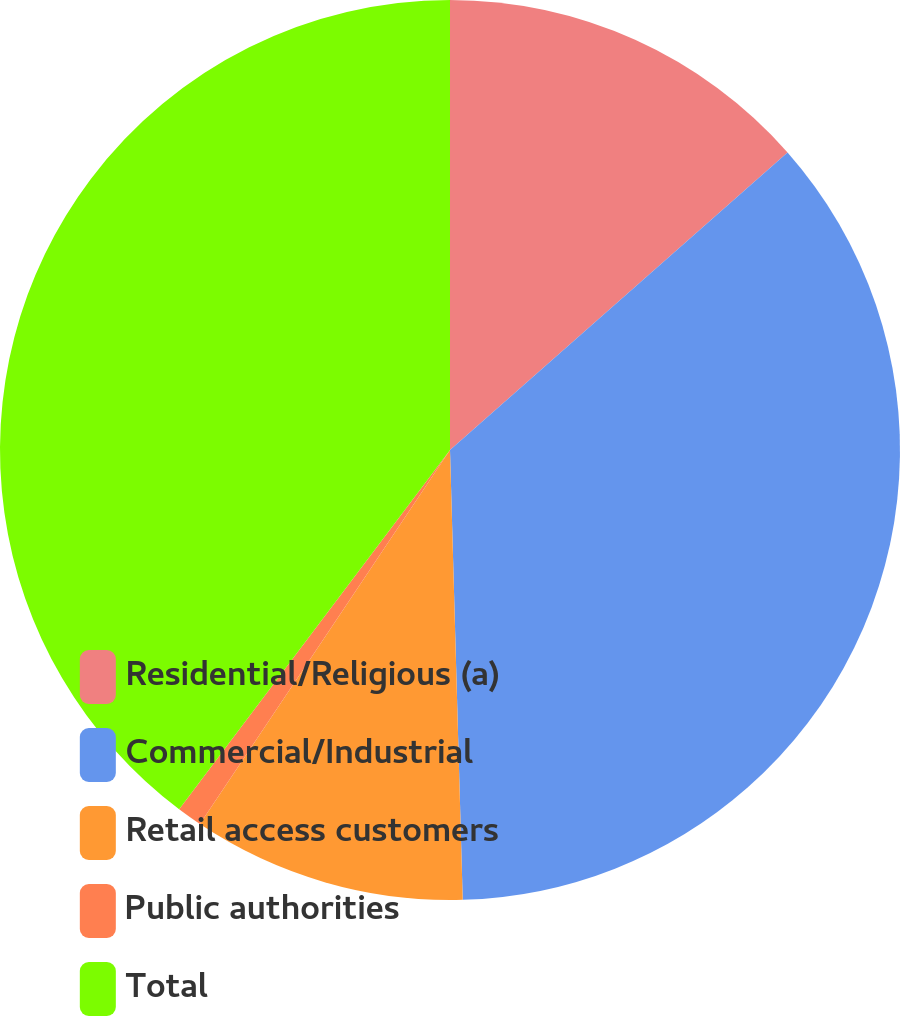<chart> <loc_0><loc_0><loc_500><loc_500><pie_chart><fcel>Residential/Religious (a)<fcel>Commercial/Industrial<fcel>Retail access customers<fcel>Public authorities<fcel>Total<nl><fcel>13.5%<fcel>36.05%<fcel>9.83%<fcel>0.9%<fcel>39.72%<nl></chart> 